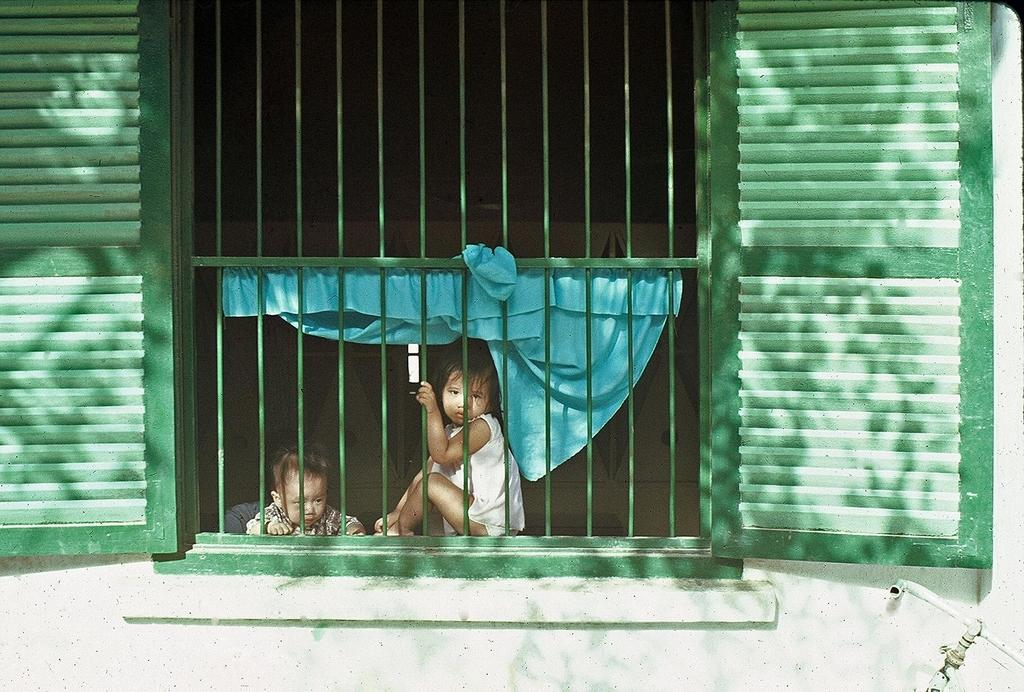What is located in the foreground of the picture? In the foreground of the picture, there are windows, a wall, an iron grill, kids, a curtain, and a pipe. What can be seen through the windows in the foreground? The background of the image is dark, so it is difficult to see through the windows. What is the material of the curtain in the foreground? The curtain in the foreground is made of an unspecified material. How many kids are visible in the foreground of the picture? There are kids in the foreground of the picture, but the exact number is not specified. What type of art is displayed on the wall in the foreground of the picture? There is no mention of any art displayed on the wall in the foreground of the picture. Can you see a frog in the picture? There is no mention of a frog in the picture. What kind of pet do the kids have in the picture? There is no mention of a pet in the picture. 